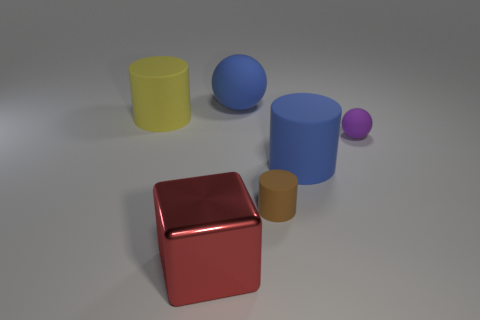Are there any other things that have the same shape as the large metallic thing?
Offer a very short reply. No. How many shiny objects are either yellow blocks or blue cylinders?
Give a very brief answer. 0. There is a brown object; is its shape the same as the big blue object that is in front of the large matte ball?
Provide a short and direct response. Yes. Is the number of shiny objects that are in front of the purple matte ball greater than the number of big rubber things behind the blue sphere?
Give a very brief answer. Yes. Is there anything else that is the same color as the metal block?
Make the answer very short. No. Is there a big blue rubber object behind the blue matte thing that is in front of the big cylinder to the left of the large red thing?
Offer a terse response. Yes. Does the large blue thing that is behind the yellow rubber cylinder have the same shape as the red object?
Your response must be concise. No. Is the number of things that are left of the big yellow rubber cylinder less than the number of balls that are in front of the large ball?
Provide a succinct answer. Yes. What material is the blue cylinder?
Offer a very short reply. Rubber. Do the big sphere and the big matte cylinder that is in front of the tiny ball have the same color?
Make the answer very short. Yes. 